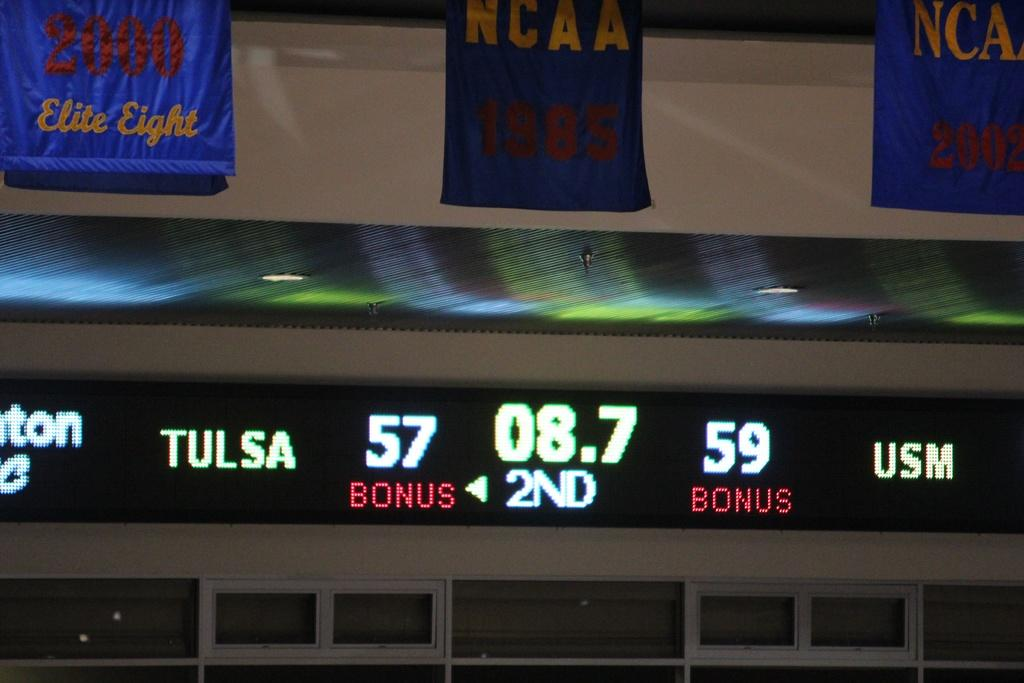<image>
Render a clear and concise summary of the photo. A scoreboard shows that USM is leading Tulsa 59-57. 